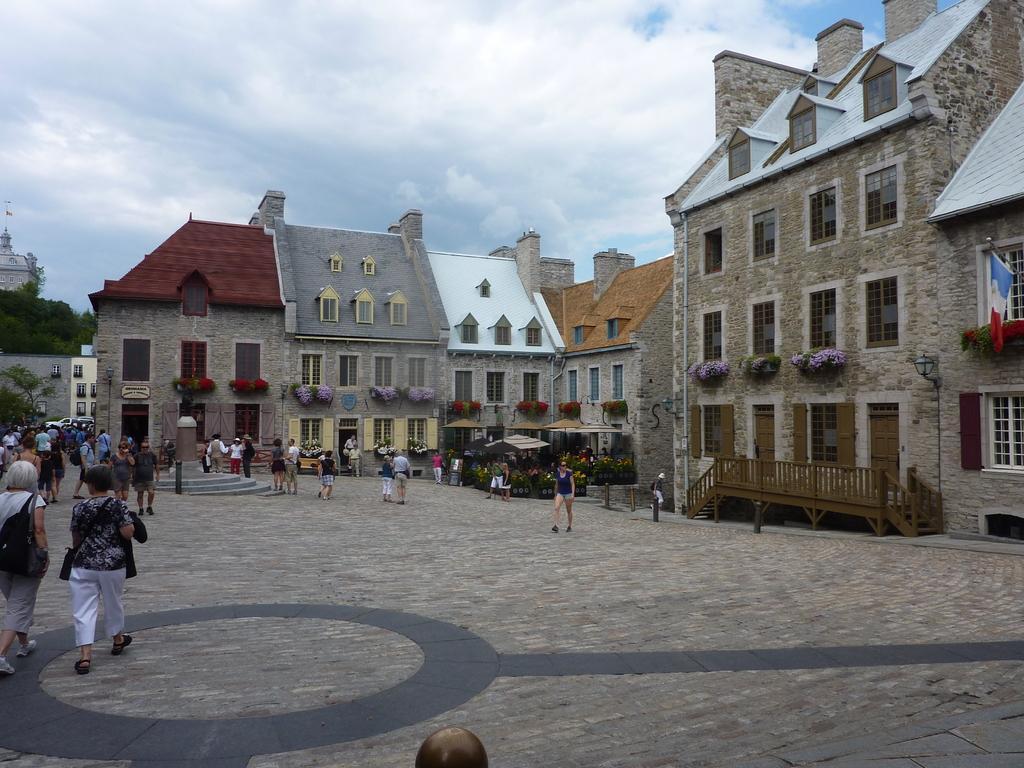How would you summarize this image in a sentence or two? In this picture we can see buildings with windows and a flower pot with plants and for this house we have fence with steps and in front of this houses we have a path where a people are standing, walking and here it is a flag attached to the window and above this buildings we have sky so cloudy and at the back of this buildings we have trees. 